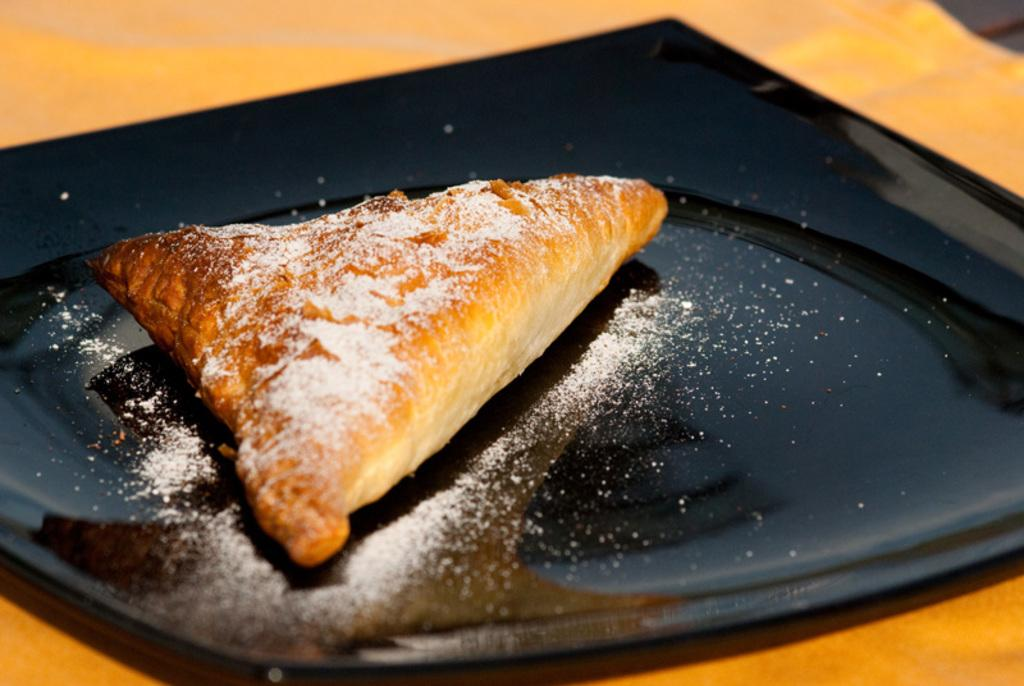What is the main subject of the image? There is a food item in the image. What is the food item placed on? The food item is on a black plate. What color is the surface beneath the black plate? The black plate is on an orange surface. Can you tell me how many toes are visible in the image? There are no toes visible in the image; it features a food item on a black plate on an orange surface. 